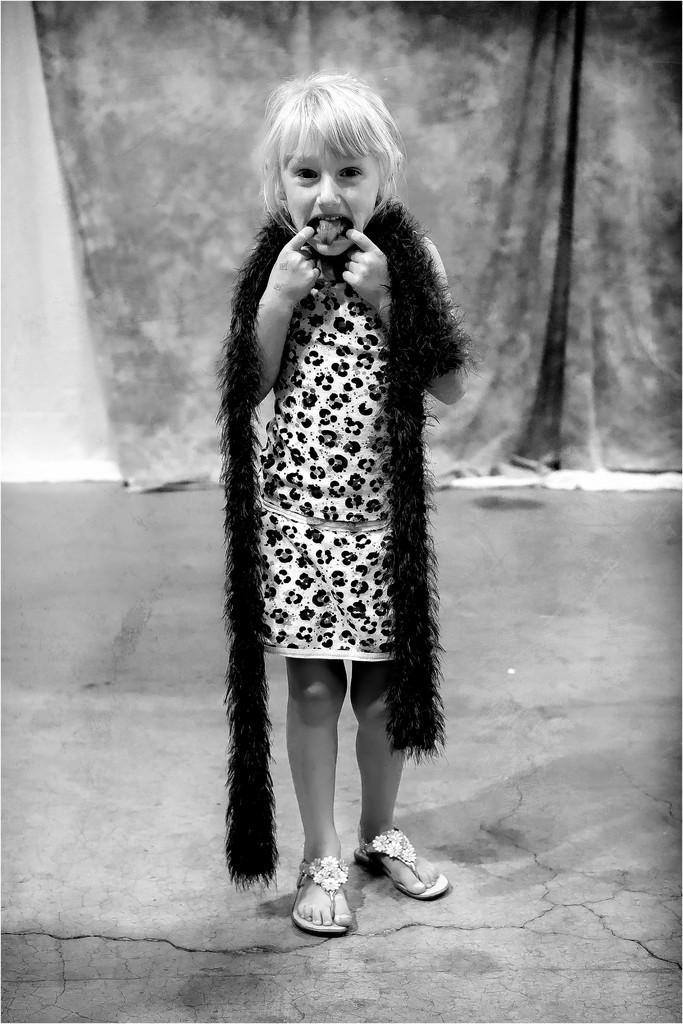How would you summarize this image in a sentence or two? This is a black and white image in this image in the center there is one girl standing, and in the background there is a curtain at the bottom there is floor. 